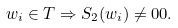<formula> <loc_0><loc_0><loc_500><loc_500>w _ { i } \in T \Rightarrow S _ { 2 } ( w _ { i } ) \neq 0 0 .</formula> 